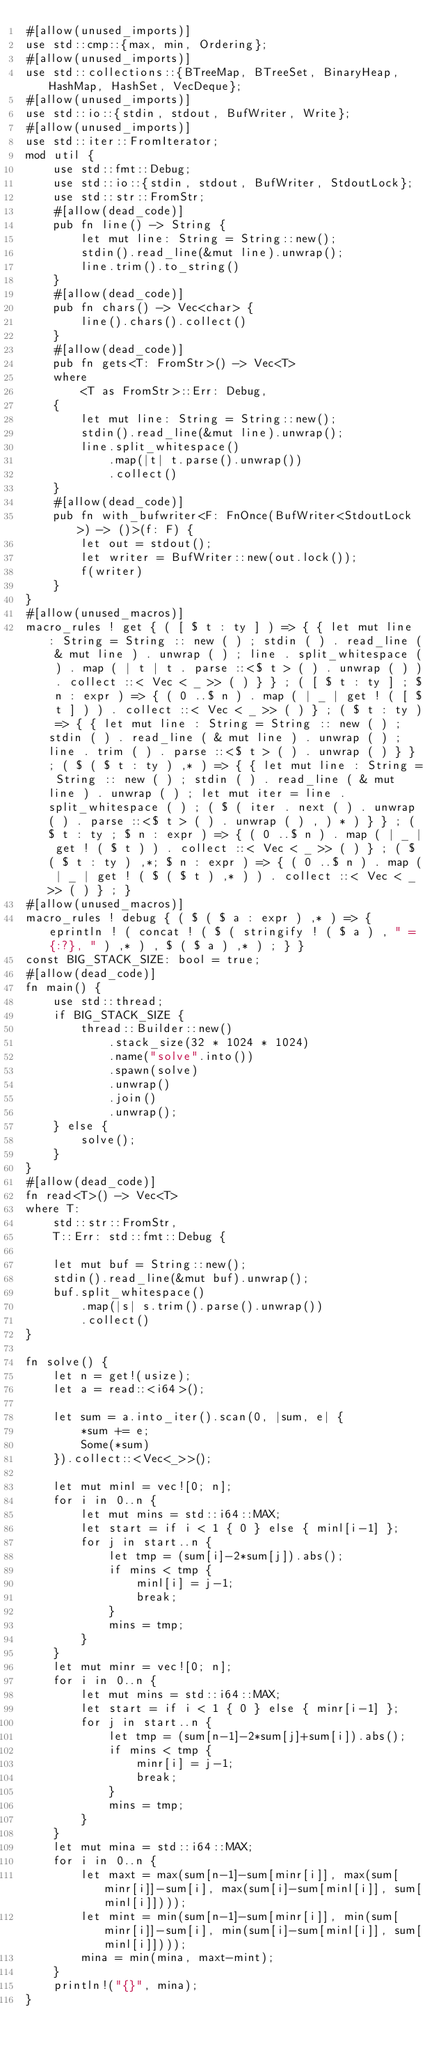<code> <loc_0><loc_0><loc_500><loc_500><_Rust_>#[allow(unused_imports)]
use std::cmp::{max, min, Ordering};
#[allow(unused_imports)]
use std::collections::{BTreeMap, BTreeSet, BinaryHeap, HashMap, HashSet, VecDeque};
#[allow(unused_imports)]
use std::io::{stdin, stdout, BufWriter, Write};
#[allow(unused_imports)]
use std::iter::FromIterator;
mod util {
    use std::fmt::Debug;
    use std::io::{stdin, stdout, BufWriter, StdoutLock};
    use std::str::FromStr;
    #[allow(dead_code)]
    pub fn line() -> String {
        let mut line: String = String::new();
        stdin().read_line(&mut line).unwrap();
        line.trim().to_string()
    }
    #[allow(dead_code)]
    pub fn chars() -> Vec<char> {
        line().chars().collect()
    }
    #[allow(dead_code)]
    pub fn gets<T: FromStr>() -> Vec<T>
    where
        <T as FromStr>::Err: Debug,
    {
        let mut line: String = String::new();
        stdin().read_line(&mut line).unwrap();
        line.split_whitespace()
            .map(|t| t.parse().unwrap())
            .collect()
    }
    #[allow(dead_code)]
    pub fn with_bufwriter<F: FnOnce(BufWriter<StdoutLock>) -> ()>(f: F) {
        let out = stdout();
        let writer = BufWriter::new(out.lock());
        f(writer)
    }
}
#[allow(unused_macros)]
macro_rules ! get { ( [ $ t : ty ] ) => { { let mut line : String = String :: new ( ) ; stdin ( ) . read_line ( & mut line ) . unwrap ( ) ; line . split_whitespace ( ) . map ( | t | t . parse ::<$ t > ( ) . unwrap ( ) ) . collect ::< Vec < _ >> ( ) } } ; ( [ $ t : ty ] ; $ n : expr ) => { ( 0 ..$ n ) . map ( | _ | get ! ( [ $ t ] ) ) . collect ::< Vec < _ >> ( ) } ; ( $ t : ty ) => { { let mut line : String = String :: new ( ) ; stdin ( ) . read_line ( & mut line ) . unwrap ( ) ; line . trim ( ) . parse ::<$ t > ( ) . unwrap ( ) } } ; ( $ ( $ t : ty ) ,* ) => { { let mut line : String = String :: new ( ) ; stdin ( ) . read_line ( & mut line ) . unwrap ( ) ; let mut iter = line . split_whitespace ( ) ; ( $ ( iter . next ( ) . unwrap ( ) . parse ::<$ t > ( ) . unwrap ( ) , ) * ) } } ; ( $ t : ty ; $ n : expr ) => { ( 0 ..$ n ) . map ( | _ | get ! ( $ t ) ) . collect ::< Vec < _ >> ( ) } ; ( $ ( $ t : ty ) ,*; $ n : expr ) => { ( 0 ..$ n ) . map ( | _ | get ! ( $ ( $ t ) ,* ) ) . collect ::< Vec < _ >> ( ) } ; }
#[allow(unused_macros)]
macro_rules ! debug { ( $ ( $ a : expr ) ,* ) => { eprintln ! ( concat ! ( $ ( stringify ! ( $ a ) , " = {:?}, " ) ,* ) , $ ( $ a ) ,* ) ; } }
const BIG_STACK_SIZE: bool = true;
#[allow(dead_code)]
fn main() {
    use std::thread;
    if BIG_STACK_SIZE {
        thread::Builder::new()
            .stack_size(32 * 1024 * 1024)
            .name("solve".into())
            .spawn(solve)
            .unwrap()
            .join()
            .unwrap();
    } else {
        solve();
    }
}
#[allow(dead_code)]
fn read<T>() -> Vec<T>
where T:
    std::str::FromStr,
    T::Err: std::fmt::Debug {

    let mut buf = String::new();
    stdin().read_line(&mut buf).unwrap();
    buf.split_whitespace()
        .map(|s| s.trim().parse().unwrap())
        .collect()
}

fn solve() {
    let n = get!(usize);
    let a = read::<i64>();

    let sum = a.into_iter().scan(0, |sum, e| {
        *sum += e;
        Some(*sum)
    }).collect::<Vec<_>>();

    let mut minl = vec![0; n];
    for i in 0..n {
        let mut mins = std::i64::MAX;
        let start = if i < 1 { 0 } else { minl[i-1] };
        for j in start..n {
            let tmp = (sum[i]-2*sum[j]).abs();
            if mins < tmp {
                minl[i] = j-1;
                break;
            }
            mins = tmp;
        }
    }
    let mut minr = vec![0; n];
    for i in 0..n {
        let mut mins = std::i64::MAX;
        let start = if i < 1 { 0 } else { minr[i-1] };
        for j in start..n {
            let tmp = (sum[n-1]-2*sum[j]+sum[i]).abs();
            if mins < tmp {
                minr[i] = j-1;
                break;
            }
            mins = tmp;
        }
    }
    let mut mina = std::i64::MAX;
    for i in 0..n {
        let maxt = max(sum[n-1]-sum[minr[i]], max(sum[minr[i]]-sum[i], max(sum[i]-sum[minl[i]], sum[minl[i]])));
        let mint = min(sum[n-1]-sum[minr[i]], min(sum[minr[i]]-sum[i], min(sum[i]-sum[minl[i]], sum[minl[i]])));
        mina = min(mina, maxt-mint);
    }
    println!("{}", mina);
}
</code> 